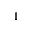Convert formula to latex. <formula><loc_0><loc_0><loc_500><loc_500>1</formula> 